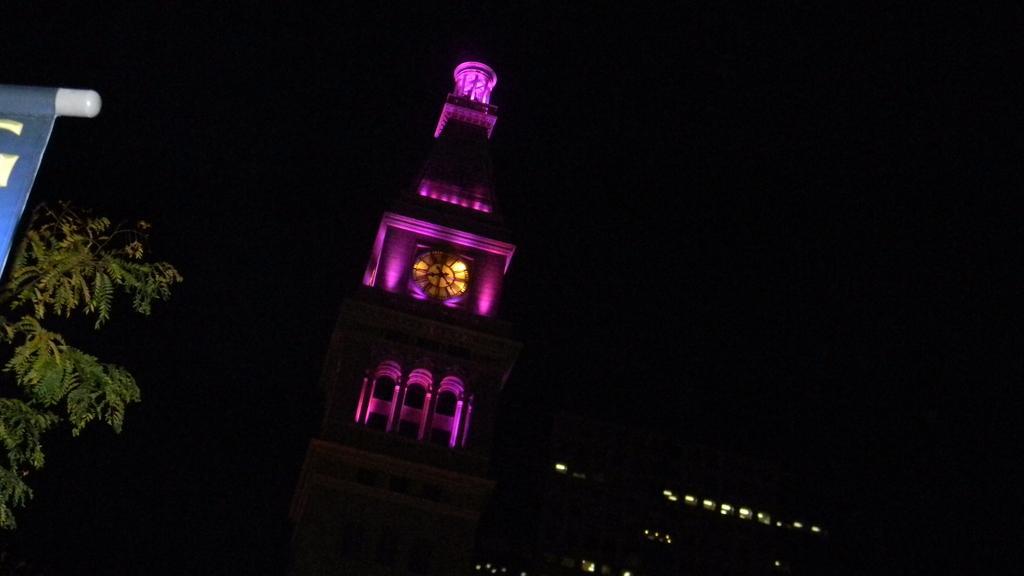Could you give a brief overview of what you see in this image? In this image, we can see a clock tower and in the middle we can see a clock, on the left side we can see a tree and in the background we can see the dark. 